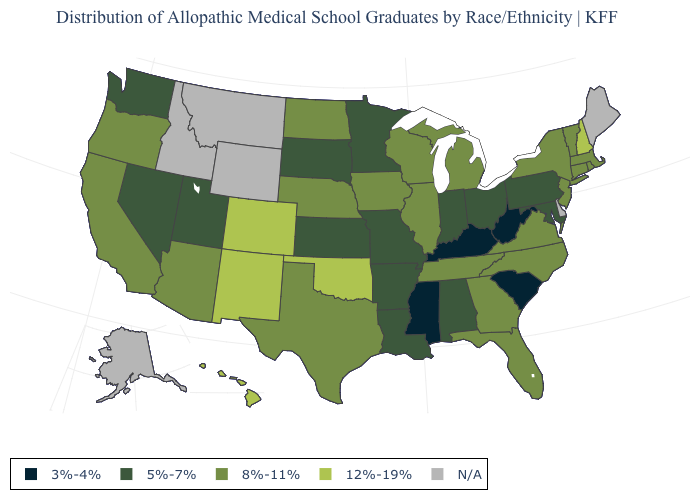Name the states that have a value in the range 5%-7%?
Quick response, please. Alabama, Arkansas, Indiana, Kansas, Louisiana, Maryland, Minnesota, Missouri, Nevada, Ohio, Pennsylvania, South Dakota, Utah, Washington. Name the states that have a value in the range N/A?
Give a very brief answer. Alaska, Delaware, Idaho, Maine, Montana, Wyoming. How many symbols are there in the legend?
Answer briefly. 5. Which states have the lowest value in the West?
Concise answer only. Nevada, Utah, Washington. Name the states that have a value in the range N/A?
Short answer required. Alaska, Delaware, Idaho, Maine, Montana, Wyoming. Does West Virginia have the lowest value in the USA?
Give a very brief answer. Yes. What is the lowest value in states that border North Carolina?
Be succinct. 3%-4%. What is the value of Connecticut?
Give a very brief answer. 8%-11%. What is the lowest value in states that border Rhode Island?
Short answer required. 8%-11%. Among the states that border Colorado , which have the lowest value?
Give a very brief answer. Kansas, Utah. What is the value of Montana?
Keep it brief. N/A. Among the states that border North Dakota , which have the lowest value?
Quick response, please. Minnesota, South Dakota. Name the states that have a value in the range 12%-19%?
Concise answer only. Colorado, Hawaii, New Hampshire, New Mexico, Oklahoma. Does the first symbol in the legend represent the smallest category?
Give a very brief answer. Yes. 